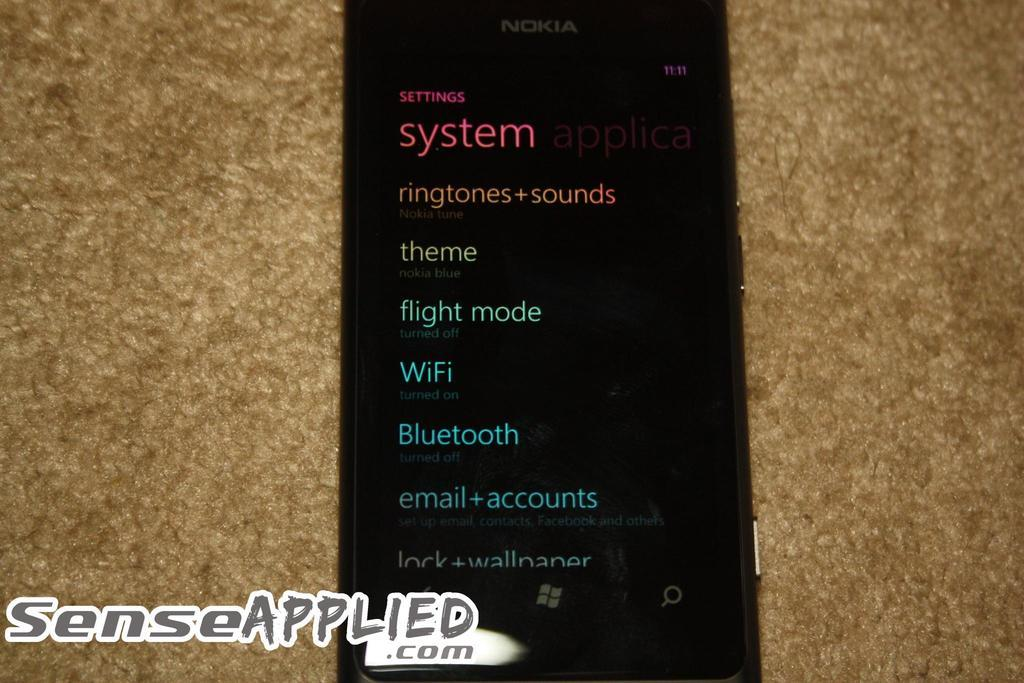<image>
Summarize the visual content of the image. An information page that lists settings for a phone like ringtones,theme,bluetoothand email. 